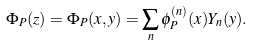<formula> <loc_0><loc_0><loc_500><loc_500>\Phi _ { P } ( z ) = \Phi _ { P } ( x , y ) = \sum _ { n } \phi _ { P } ^ { ( n ) } ( x ) Y _ { n } ( y ) .</formula> 